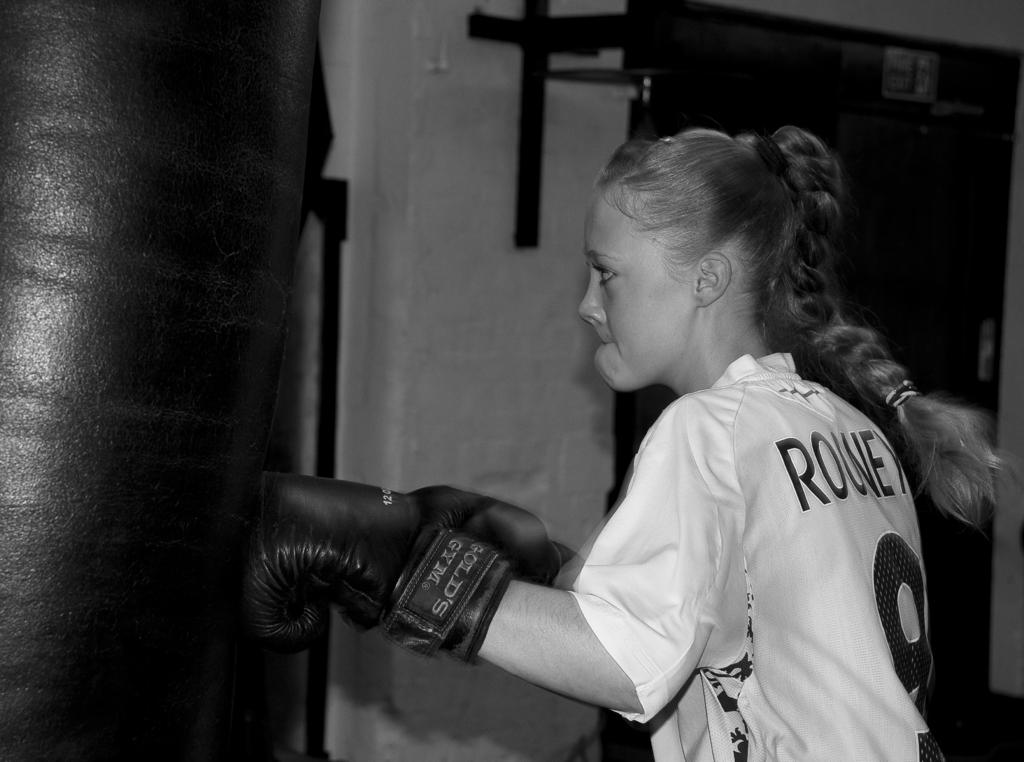Who is the main subject in the image? There is a girl in the image. Where is the girl located in the image? The girl is on the right side of the image. What is the girl wearing? The girl is wearing boxing gloves. What can be seen on the left side of the image? There is a punching bag on the left side of the image. What might be a possible exit or entrance in the background? It appears to be a door in the background. What type of object can be seen in the background? There is a metal object in the background. How does the girl account for her losses in the image? There is no indication of losses or any account in the image. 